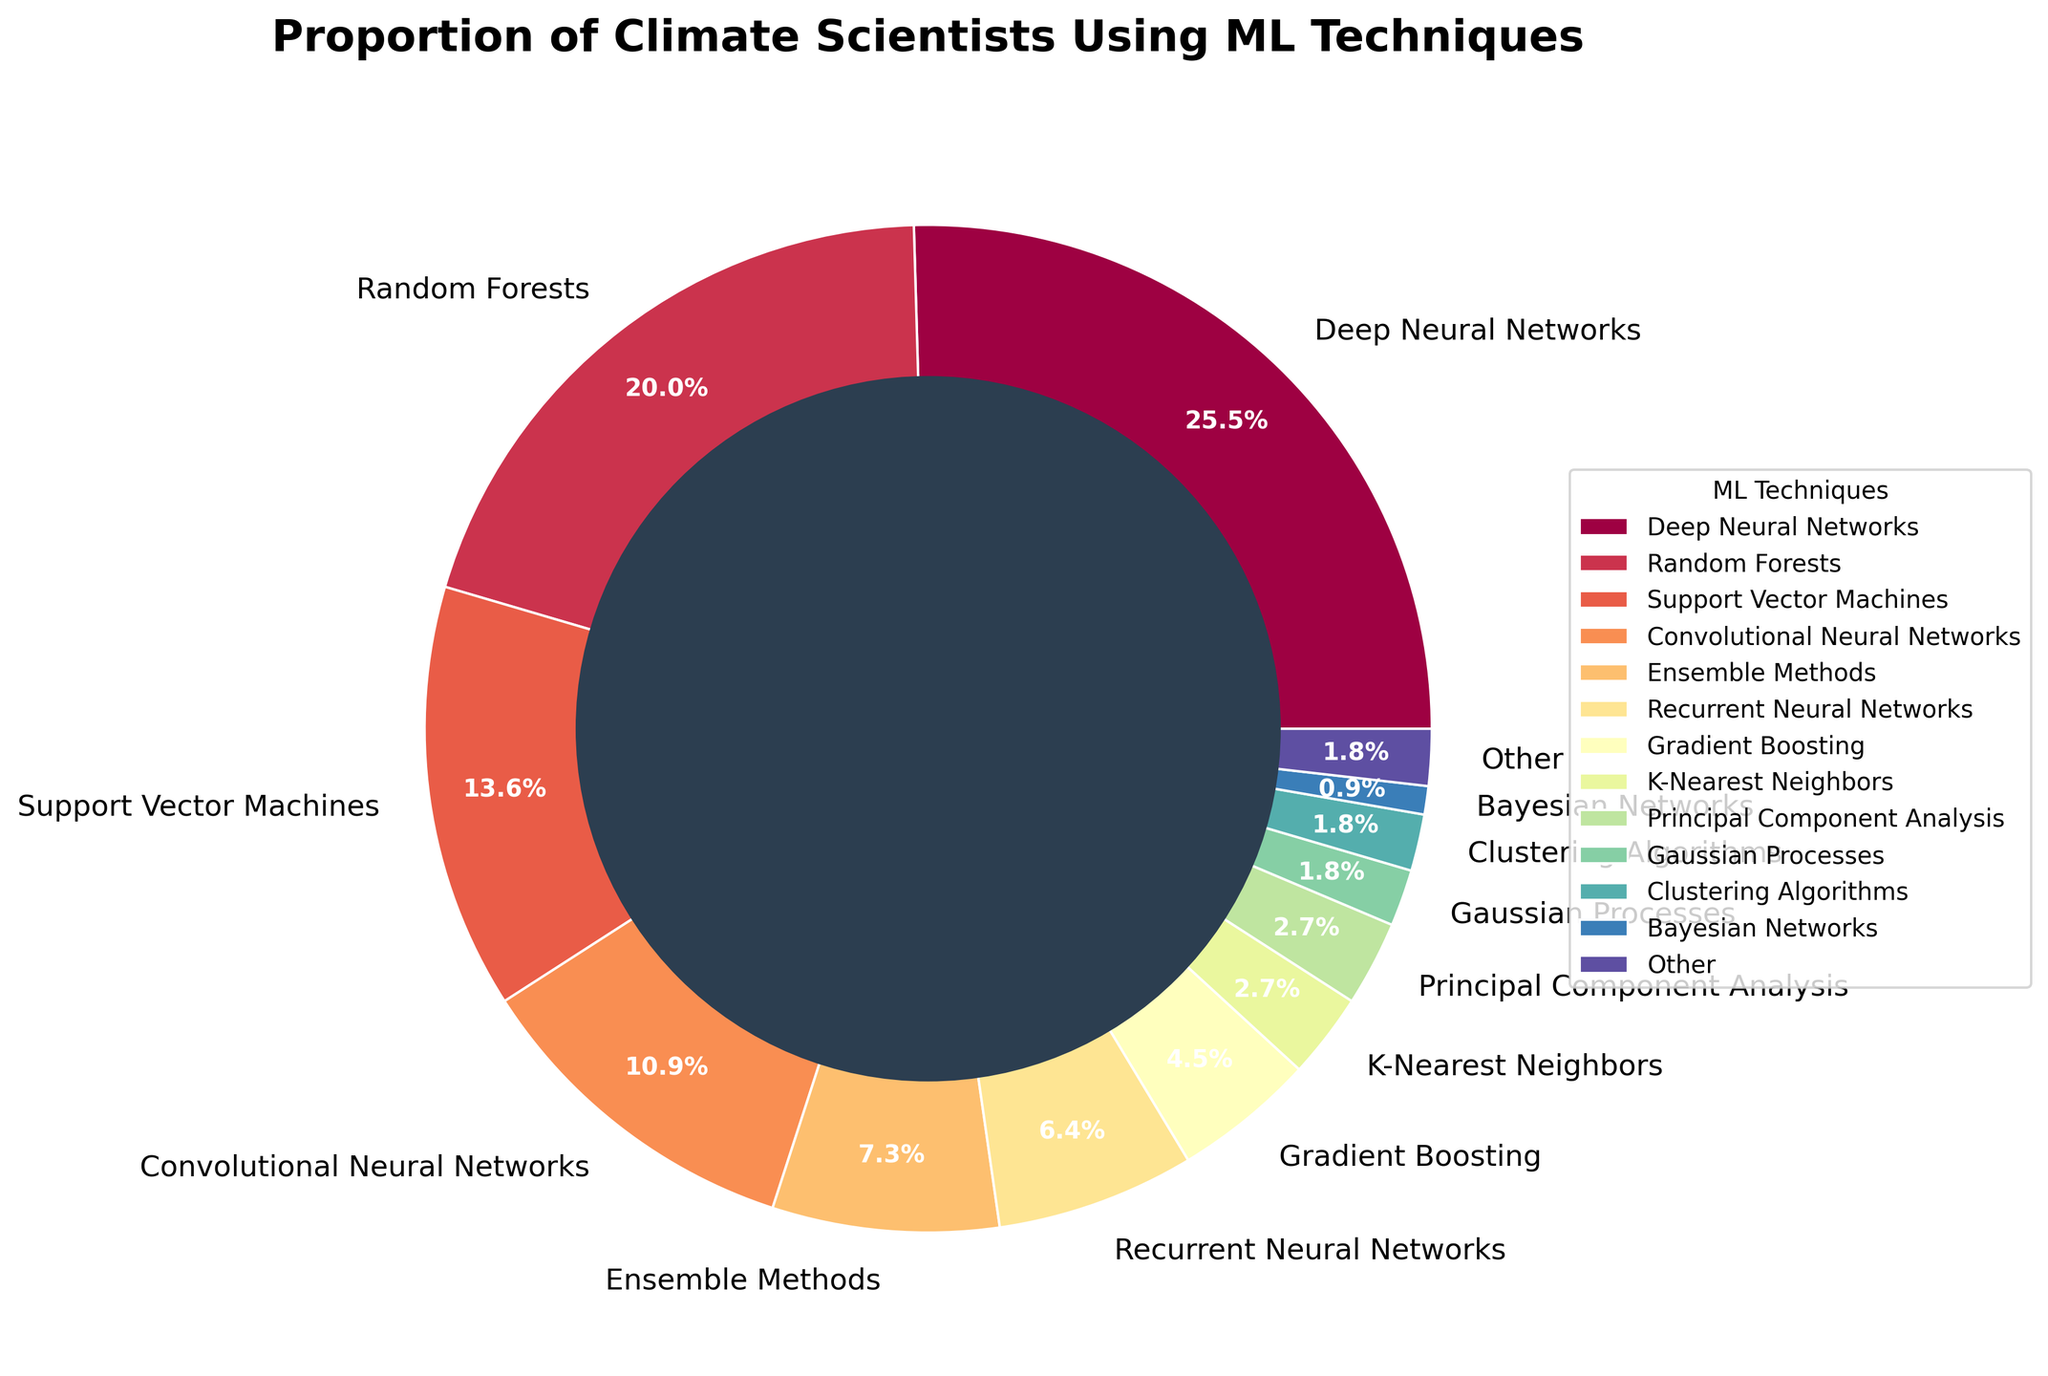Which technique has the highest proportion among climate scientists? The technique with the highest proportion is found at the largest wedge in the pie chart. The largest wedge in the pie chart belongs to Deep Neural Networks.
Answer: Deep Neural Networks What is the combined percentage of climate scientists using Deep Neural Networks, Random Forests, and Support Vector Machines? Sum the percentages for Deep Neural Networks (28), Random Forests (22), and Support Vector Machines (15). 28 + 22 + 15 = 65.
Answer: 65% Which machine learning techniques are used by less than 5% of climate scientists each? Identify the wedges corresponding to percentages less than 5% in the pie chart. K-Nearest Neighbors (3%), Principal Component Analysis (3%), Gaussian Processes (2%), Clustering Algorithms (2%), and Bayesian Networks (1%) all account for less than 5%.
Answer: K-Nearest Neighbors, Principal Component Analysis, Gaussian Processes, Clustering Algorithms, Bayesian Networks What is the difference in percentage between the usage of Deep Neural Networks and Recurrent Neural Networks? Subtract the percentage of Recurrent Neural Networks (7) from Deep Neural Networks (28). 28 - 7 = 21.
Answer: 21% What proportion of climate scientists use either Convolutional Neural Networks or Ensemble Methods? Sum the percentages for Convolutional Neural Networks (12) and Ensemble Methods (8). 12 + 8 = 20.
Answer: 20% How many techniques are used by at least 10% of climate scientists each? Count the wedges in the pie chart that represent 10% or more. The techniques are Deep Neural Networks, Random Forests, Support Vector Machines, and Convolutional Neural Networks. This sums up to 4 techniques.
Answer: 4 Which technique has exactly 2% representation among climate scientists, and how does it compare to the technique with the least usage? Find the wedges representing 2%, which are Gaussian Processes, Clustering Algorithms, and "Other". The technique with the least usage is Bayesian Networks (1%). Therefore, 2% is greater than 1%.
Answer: Gaussian Processes, Clustering Algorithms, Other; greater Is the percentage of climate scientists using Ensemble Methods greater than or less than those using Support Vector Machines? By how much? Compare the percentage for Ensemble Methods (8) and Support Vector Machines (15). Subtract the smaller from the larger. 15 - 8 = 7. Ensemble Methods is less by 7%.
Answer: Less by 7% What is the relative size of the wedge representing Random Forests compared to Recurrent Neural Networks? Compare the percentages for Random Forests (22) and Recurrent Neural Networks (7). Since 22 is greater than 7, Random Forests has a larger wedge.
Answer: Random Forests is larger 